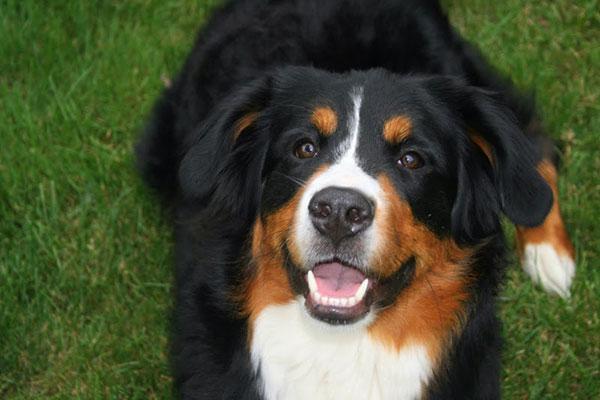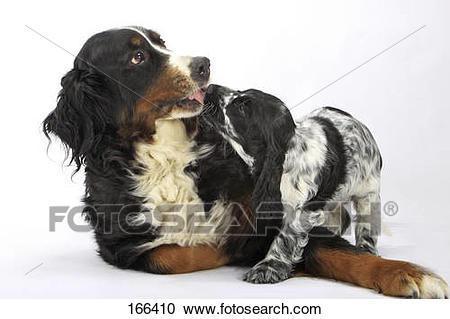The first image is the image on the left, the second image is the image on the right. Evaluate the accuracy of this statement regarding the images: "In one of the images there are 2 dogs playing on the grass.". Is it true? Answer yes or no. No. The first image is the image on the left, the second image is the image on the right. Assess this claim about the two images: "The left image contains a single standing dog, and the right image shows two dogs interacting outdoors.". Correct or not? Answer yes or no. No. 